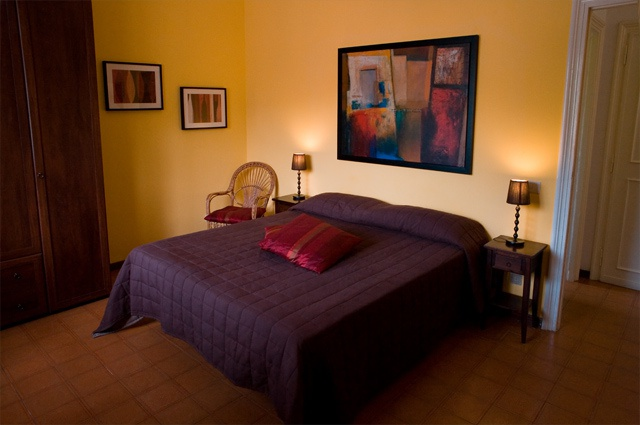Describe the objects in this image and their specific colors. I can see bed in black, maroon, and purple tones and chair in black, brown, maroon, and tan tones in this image. 